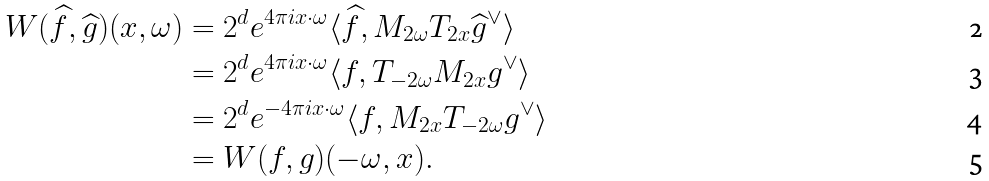Convert formula to latex. <formula><loc_0><loc_0><loc_500><loc_500>W ( \widehat { f } , \widehat { g } ) ( x , \omega ) & = 2 ^ { d } e ^ { 4 \pi i x \cdot \omega } \langle \widehat { f } , M _ { 2 \omega } T _ { 2 x } \widehat { g } ^ { \vee } \rangle \\ & = 2 ^ { d } e ^ { 4 \pi i x \cdot \omega } \langle f , T _ { - 2 \omega } M _ { 2 x } g ^ { \vee } \rangle \\ & = 2 ^ { d } e ^ { - 4 \pi i x \cdot \omega } \langle f , M _ { 2 x } T _ { - 2 \omega } g ^ { \vee } \rangle \\ & = W ( f , g ) ( - \omega , x ) .</formula> 